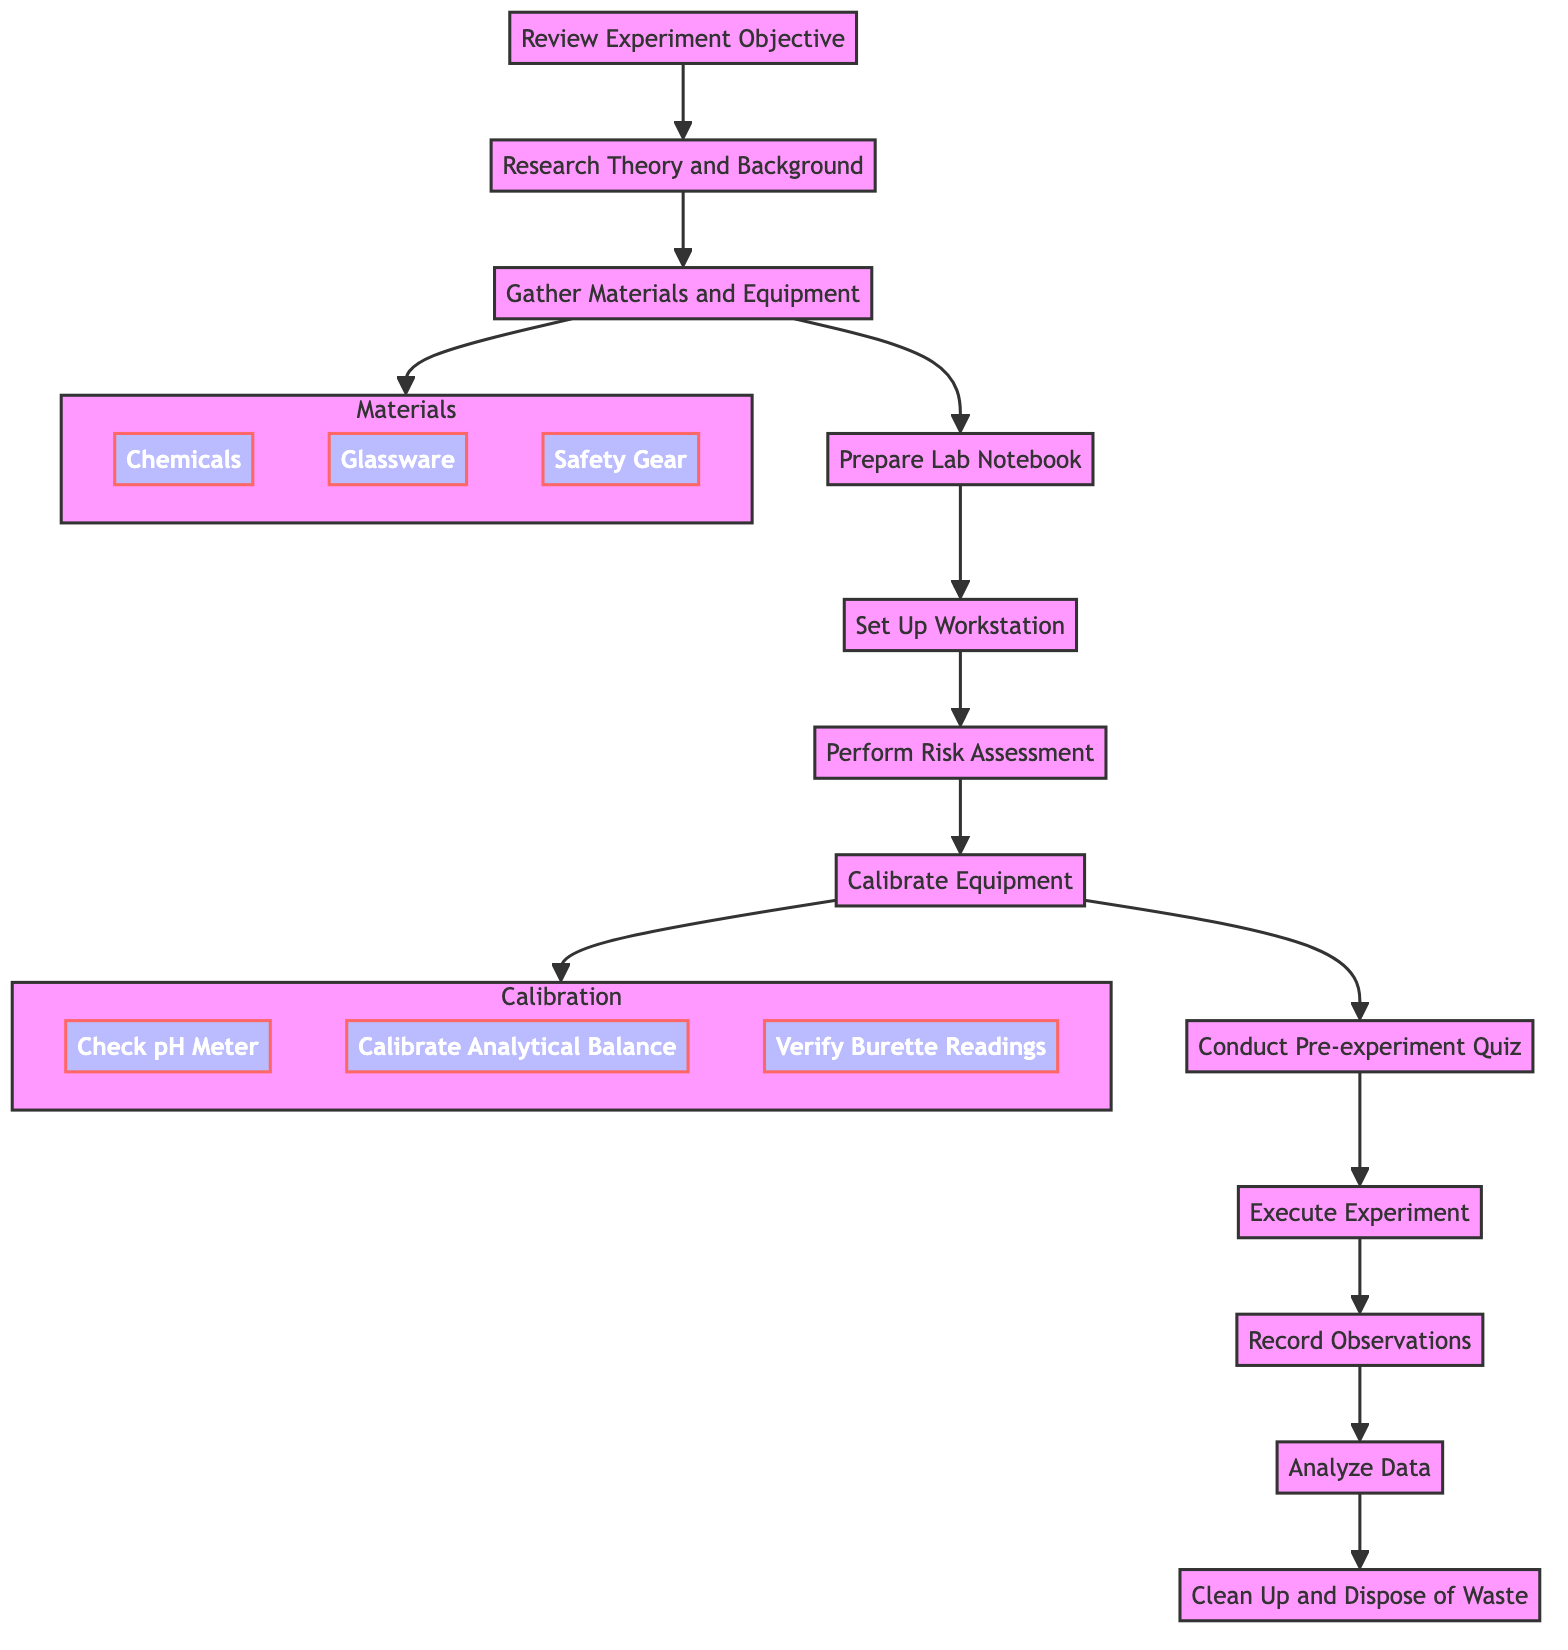What is the first step in the experiment preparation? The first step is shown at the top of the flowchart, which is "Review Experiment Objective."
Answer: Review Experiment Objective How many nodes are present in the diagram? By counting the steps listed in the flowchart, there are 12 main nodes, including the end step.
Answer: 12 Which step involves equipment calibration? The step indicating calibration is directly labeled as "Calibrate Equipment."
Answer: Calibrate Equipment What materials are required for the experiment? The required materials are detailed in the subgraph "Materials," including Chemicals, Glassware, and Safety Gear.
Answer: Chemicals, Glassware, Safety Gear What follows after conducting the pre-experiment quiz? Following the quiz step, the next step indicated in the flowchart is "Execute Experiment."
Answer: Execute Experiment Which two components are part of the Calibration step? The two specific components listed under the Calibration step are "Check pH Meter" and "Calibrate Analytical Balance."
Answer: Check pH Meter, Calibrate Analytical Balance What is the last step of the experiment preparation? The last step at the bottom of the flowchart is "Clean Up and Dispose of Waste."
Answer: Clean Up and Dispose of Waste How many subgraphs are present in the diagram? There are two subgraphs in the diagram: "Materials" and "Calibration."
Answer: 2 What step comes immediately after setting up the workstation? The immediate step following "Set Up Workstation" is "Perform Risk Assessment."
Answer: Perform Risk Assessment 